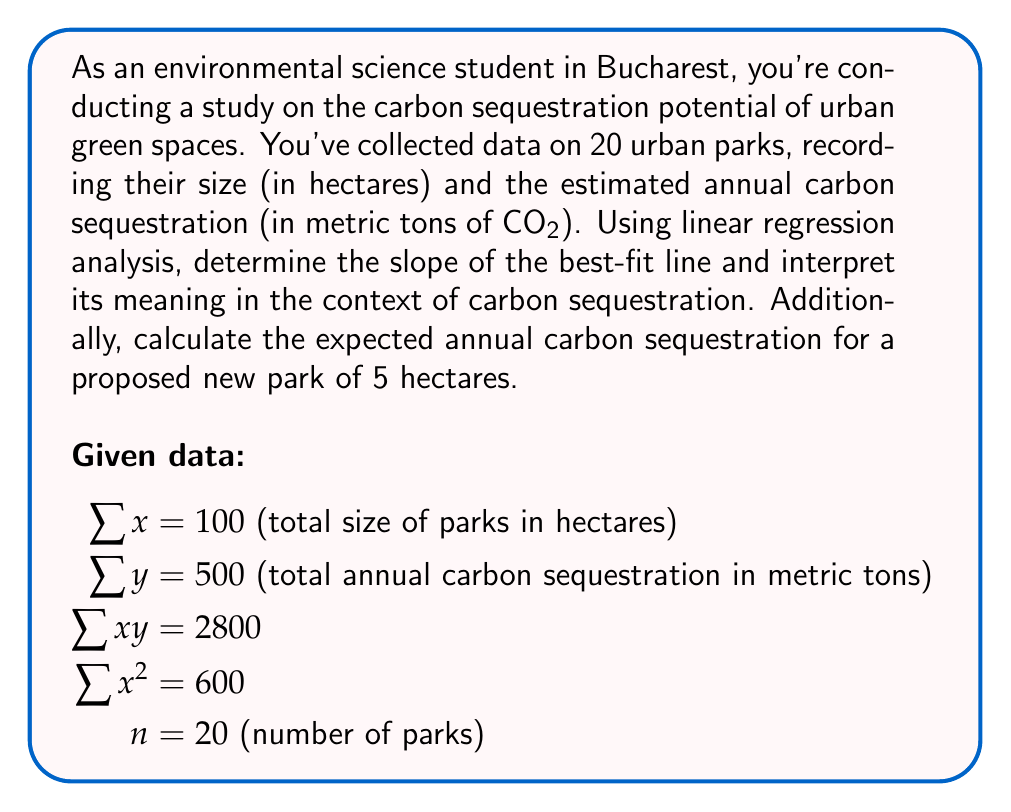Can you solve this math problem? To solve this problem, we'll use linear regression analysis to find the best-fit line equation $y = mx + b$, where $m$ is the slope and $b$ is the y-intercept.

Step 1: Calculate the slope (m) using the formula:

$$ m = \frac{n\sum xy - \sum x \sum y}{n\sum x^2 - (\sum x)^2} $$

Substituting the given values:

$$ m = \frac{20(2800) - 100(500)}{20(600) - (100)^2} $$
$$ m = \frac{56000 - 50000}{12000 - 10000} $$
$$ m = \frac{6000}{2000} = 3 $$

Step 2: Interpret the slope:
The slope of 3 means that for each additional hectare of park size, we can expect an increase of 3 metric tons of CO2 sequestered annually.

Step 3: Calculate the y-intercept (b) using the formula:

$$ b = \frac{\sum y - m\sum x}{n} $$

$$ b = \frac{500 - 3(100)}{20} = \frac{200}{20} = 10 $$

Step 4: Write the equation of the best-fit line:

$$ y = 3x + 10 $$

Step 5: Calculate the expected annual carbon sequestration for a 5-hectare park:

$$ y = 3(5) + 10 = 25 $$
Answer: The slope of the best-fit line is 3, indicating that each additional hectare of park size corresponds to an increase of 3 metric tons of CO2 sequestered annually. For a proposed new park of 5 hectares, the expected annual carbon sequestration would be 25 metric tons of CO2. 